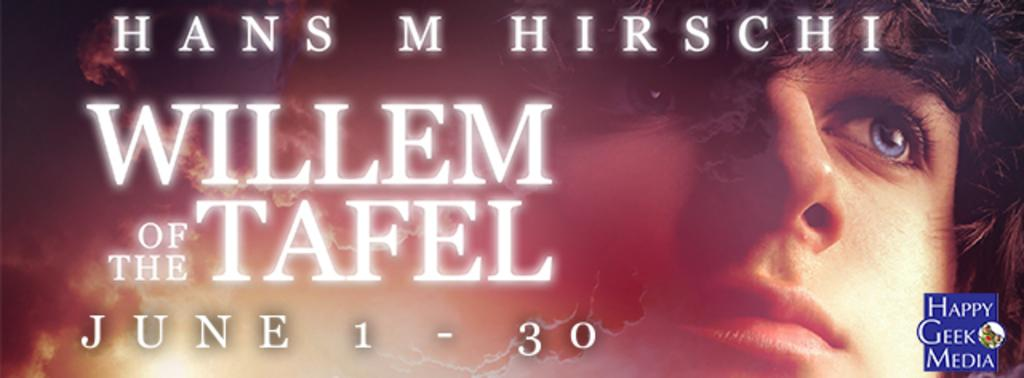What is present in the image that contains both images and text? There is a poster in the image that contains both images and text. Can you describe the content of the poster? The poster contains images and text, but the specific content is not mentioned in the provided facts. Is there any additional feature present in the image? Yes, there is a watermark in the bottom right corner of the image. What type of comfort can be seen being provided by the laborer in the image? There is no laborer present in the image, and therefore no comfort being provided. 